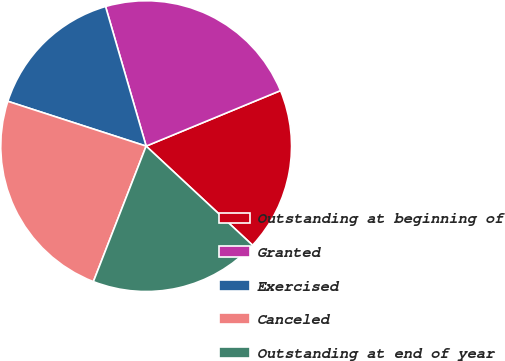Convert chart. <chart><loc_0><loc_0><loc_500><loc_500><pie_chart><fcel>Outstanding at beginning of<fcel>Granted<fcel>Exercised<fcel>Canceled<fcel>Outstanding at end of year<nl><fcel>18.17%<fcel>23.27%<fcel>15.51%<fcel>24.08%<fcel>18.98%<nl></chart> 